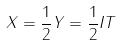Convert formula to latex. <formula><loc_0><loc_0><loc_500><loc_500>X = \frac { 1 } { 2 } Y = \frac { 1 } { 2 } I T</formula> 